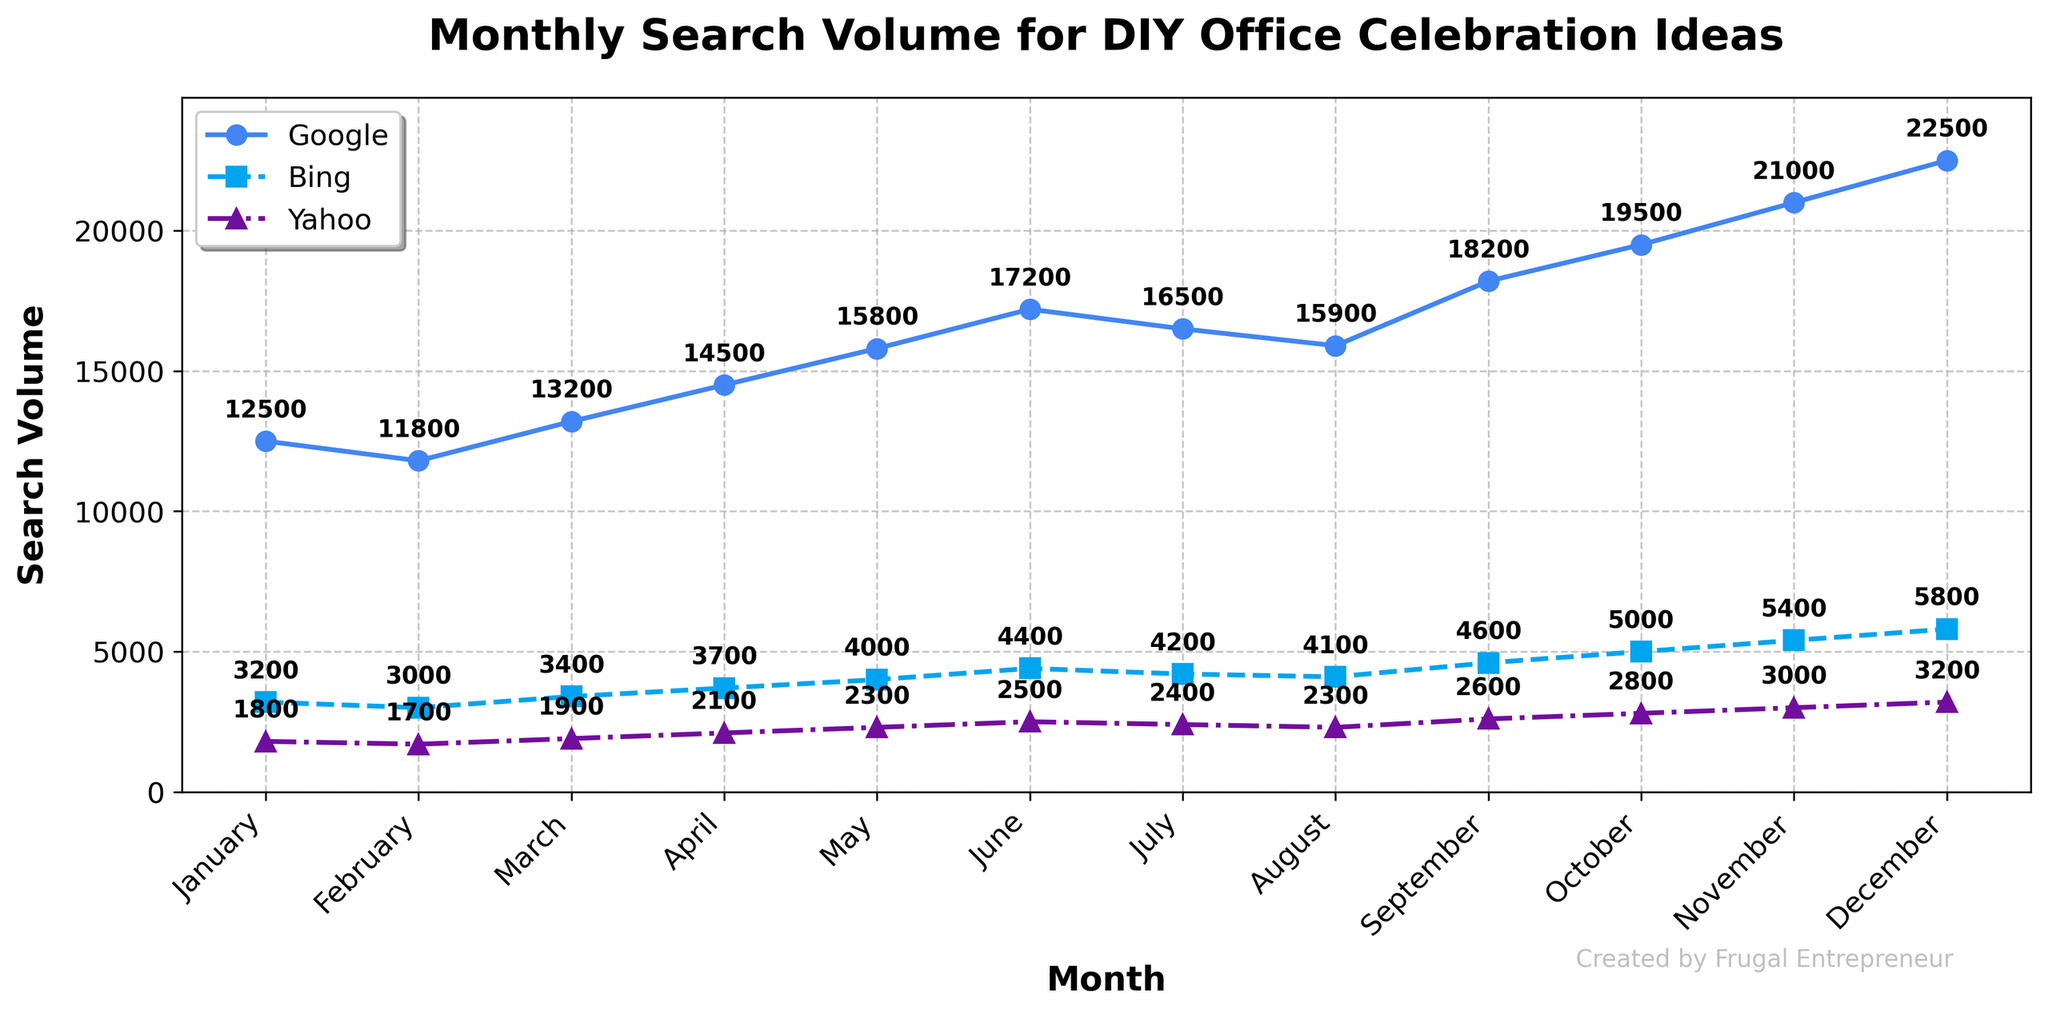What is the highest search volume recorded for Google, and in which month did it occur? The highest search volume for Google is the peak point on the corresponding line. We see that the highest point on the Google line corresponds to December, with a value of 22,500.
Answer: 22,500 in December Which search engine showed the highest increase in search volume from January to December? The increase is calculated by subtracting the January value from the December value for each search engine. For Google, it's 22,500 - 12,500 = 10,000. For Bing, it's 5,800 - 3,200 = 2,600. For Yahoo, it's 3,200 - 1,800 = 1,400. Google has the highest increase.
Answer: Google In which month did Bing have a search volume equal to Google's search volume in March? Look for the month where Bing's search volume is equal to Google's in March, which is 13,200. Bing's line never reaches that value within the year, indicating it never reaches the same search volume as Google's March value.
Answer: Never Which search engine had the smallest search volume in February, and what was the value? The shortest line segment in February shows Yahoo with 1,700, compared to Bing's 3,000 and Google's 11,800.
Answer: Yahoo with 1,700 What is the total search volume across all search engines in May? The total is the sum of the search volumes for Google, Bing, and Yahoo in May. Google (15,800) + Bing (4,000) + Yahoo (2,300) = 22,100.
Answer: 22,100 How much did Yahoo's search volume increase from July to August? The increase is the difference between the August and July values for Yahoo. 2,300 - 2,400 = 100.
Answer: 100 In which month did Yahoo show the highest search volume, and what was the value? The highest point on Yahoo's line is in December, with a search volume of 3,200.
Answer: December with 3,200 Compare the search volumes of Google and Bing in October; which engine had more searches, and by how much? Subtract Bing's October volume from Google's October volume. Google has 19,500 while Bing has 5,000. 19,500 - 5,000 = 14,500.
Answer: Google by 14,500 What is the average search volume for Bing over the first quarter (January to March)? The average is the sum of January, February, and March values divided by three. (3,200 + 3,000 + 3,400) / 3 = 3,200.
Answer: 3,200 